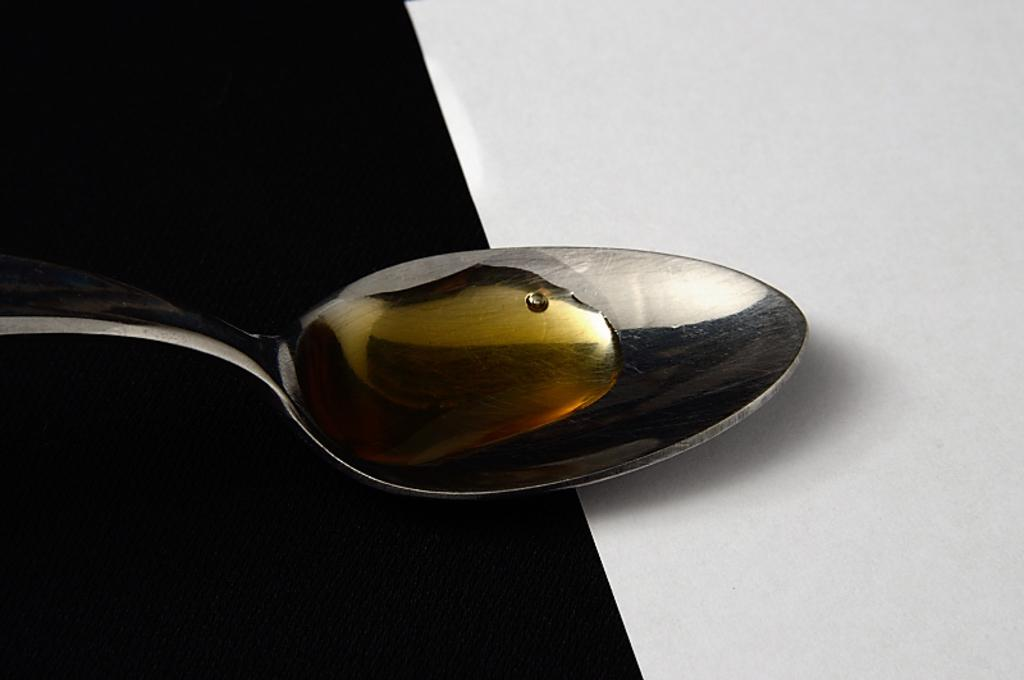What type of utensil is visible in the image? There is a silver-colored spoon in the image. What is on the spoon? There is liquid on the spoon. How would you describe the overall color scheme of the image? The background appears to be dark. What color is the surface visible in the image? The surface is white. What type of thought is being expressed by the balloon in the image? There is no balloon present in the image, and therefore no thoughts can be attributed to it. 